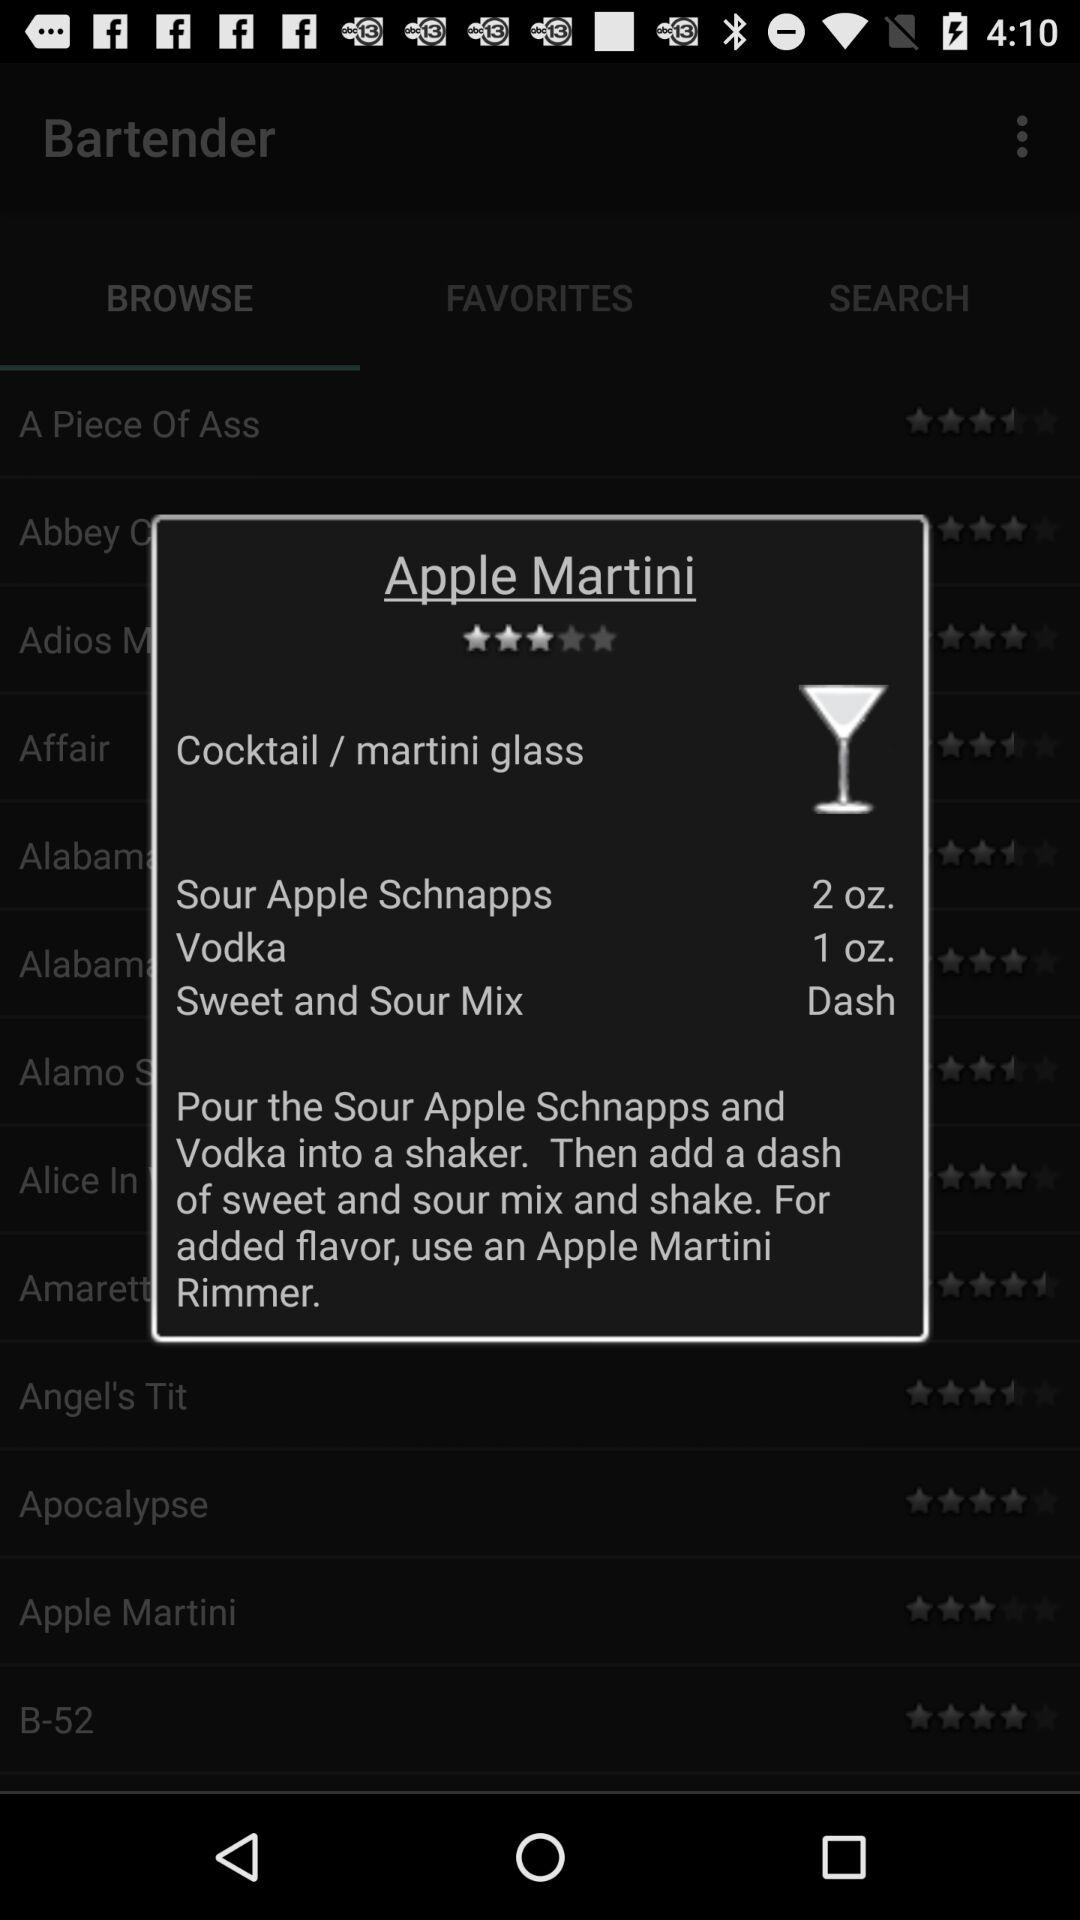How many more ounces of Sour Apple Schnapps are there than Vodka?
Answer the question using a single word or phrase. 1 